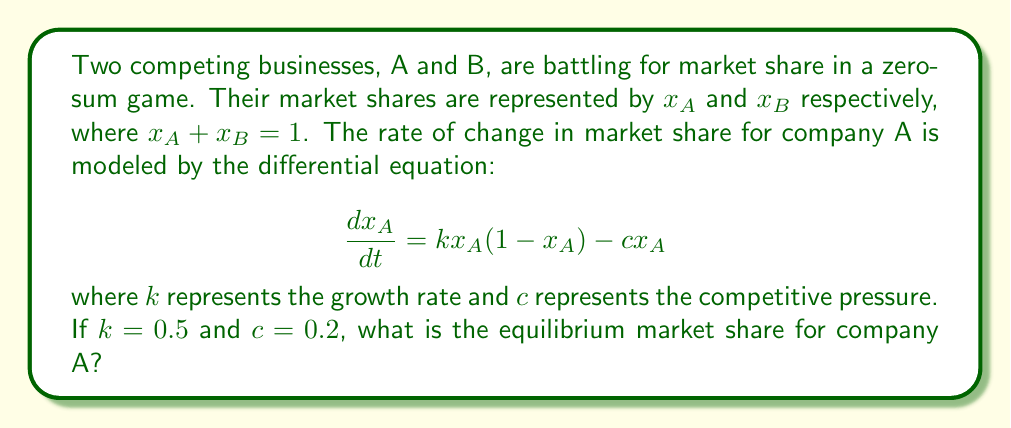Help me with this question. To find the equilibrium market share, we need to solve for $x_A$ when $\frac{dx_A}{dt} = 0$. This represents the point at which the market share is no longer changing.

Step 1: Set the differential equation equal to zero:
$$0 = kx_A(1-x_A) - cx_A$$

Step 2: Substitute the given values for $k$ and $c$:
$$0 = 0.5x_A(1-x_A) - 0.2x_A$$

Step 3: Expand the equation:
$$0 = 0.5x_A - 0.5x_A^2 - 0.2x_A$$

Step 4: Combine like terms:
$$0 = 0.3x_A - 0.5x_A^2$$

Step 5: Factor out $x_A$:
$$0 = x_A(0.3 - 0.5x_A)$$

Step 6: Solve for $x_A$. There are two solutions:
$x_A = 0$ or $0.3 - 0.5x_A = 0$

Step 7: For the non-zero solution, solve:
$$0.3 = 0.5x_A$$
$$x_A = 0.6$$

The equilibrium at $x_A = 0$ is unstable, as any small market share would grow. Therefore, the stable equilibrium is at $x_A = 0.6$.
Answer: 0.6 